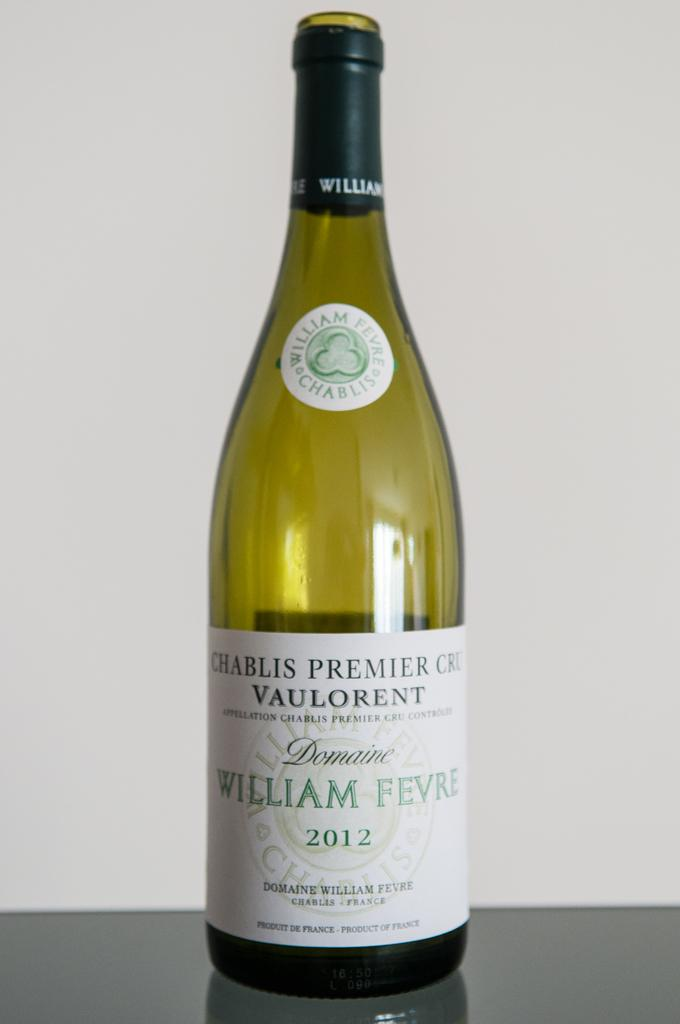Provide a one-sentence caption for the provided image. A bottle of Chablis Premier Cru Vaulorent is sitting on a table. 